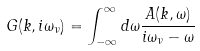Convert formula to latex. <formula><loc_0><loc_0><loc_500><loc_500>G ( k , i \omega _ { \nu } ) = \int _ { - \infty } ^ { \infty } d \omega \frac { A ( k , \omega ) } { i \omega _ { \nu } - \omega }</formula> 